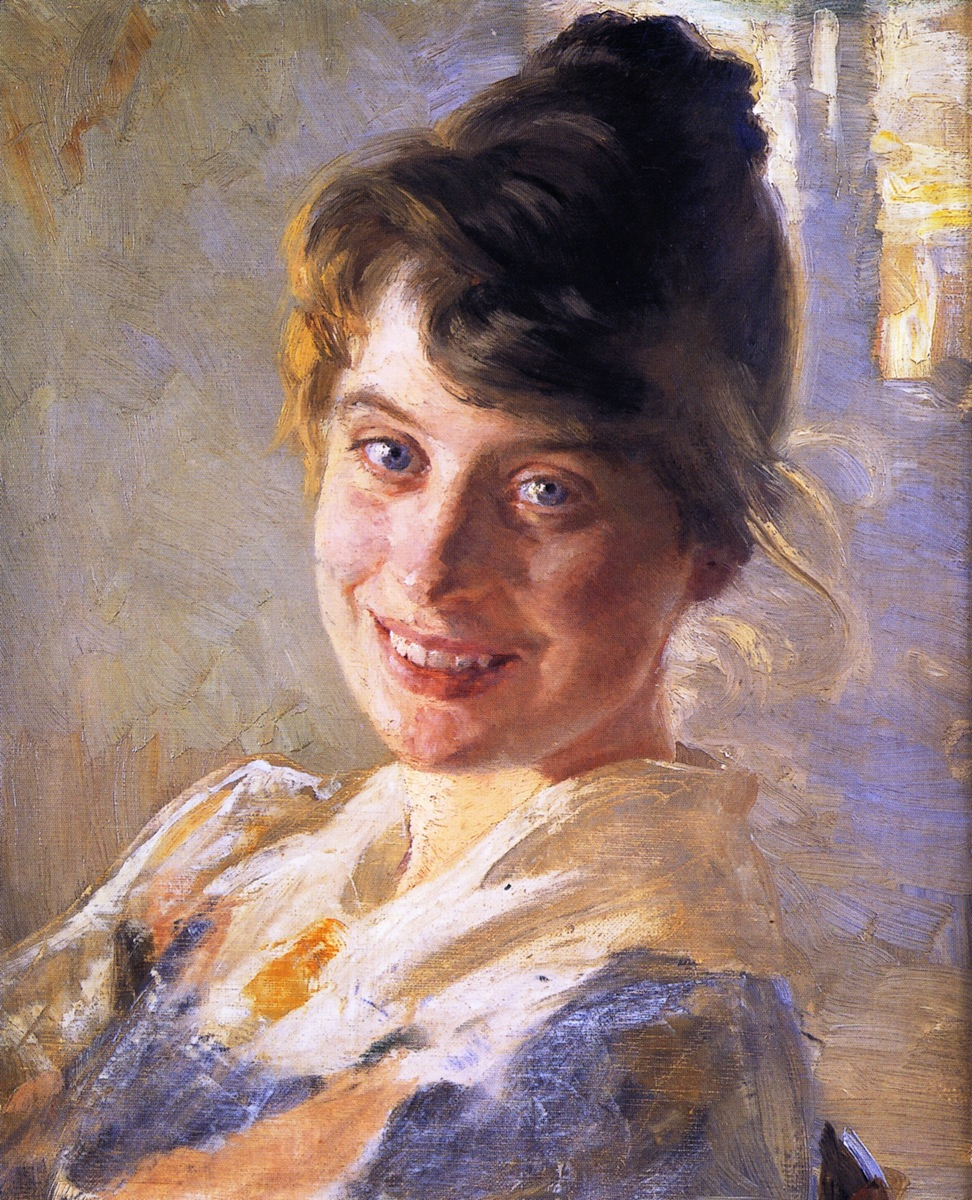Imagine you could step inside this painting. What kind of setting or environment do you think you would find yourself in? Stepping inside this painting would likely place you in a serene and cheerful environment, perhaps a garden or a charming countryside setting. The light, airy background suggests an open, well-lit space, perhaps filled with the sounds of nature and a gentle breeze. The warmth from the woman's smile would likely reflect in the overall ambiance, making it a pleasant and inviting place to be. One might imagine the scent of blooming flowers and the rustle of leaves, complementing the peaceful and joyful mood depicted in the painting. What might be some interesting stories or narratives behind the subject of this painting? The subject of this painting might be a young woman who enjoys simple pleasures and exudes a sense of contentment and joy. She could be a villager who spends her days tending to a garden, or perhaps an artist herself, finding happiness in everyday moments. Maybe she just received good news, or perhaps she is thinking fondly of loved ones. Another possibility is that she is a muse for the artist, and the painting is a tribute to their close bond, capturing a moment of genuine happiness and connection. The woman’s attire suggests simplicity and ease, which might mean she values comfort and natural beauty above all else. What if the background of this painting was to come alive and tell a story, what would it be? If the background of this painting were to come alive and tell a story, it might narrate the unfolding of a perfect spring day. The light blues and yellows hint at a late morning when the sun has fully risen and is casting a golden glow over everything. Birds might be chirping, and a gentle breeze could be causing the leaves to flutter on the trees. In this idyllic setting, the young woman could be found in a peaceful countryside cottage, preparing for a day filled with outdoor activities like gardening, painting, or reading a favorite book under a shady tree. As the day progresses, she might greet friends or family, sharing laughter and stories filled with warmth and affection. As evening falls, the colors of the sky might change to a serene mix of pinks and purples, marking the end of a joyful and fulfilling day, with the promise of many more to come. 